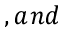Convert formula to latex. <formula><loc_0><loc_0><loc_500><loc_500>, a n d</formula> 